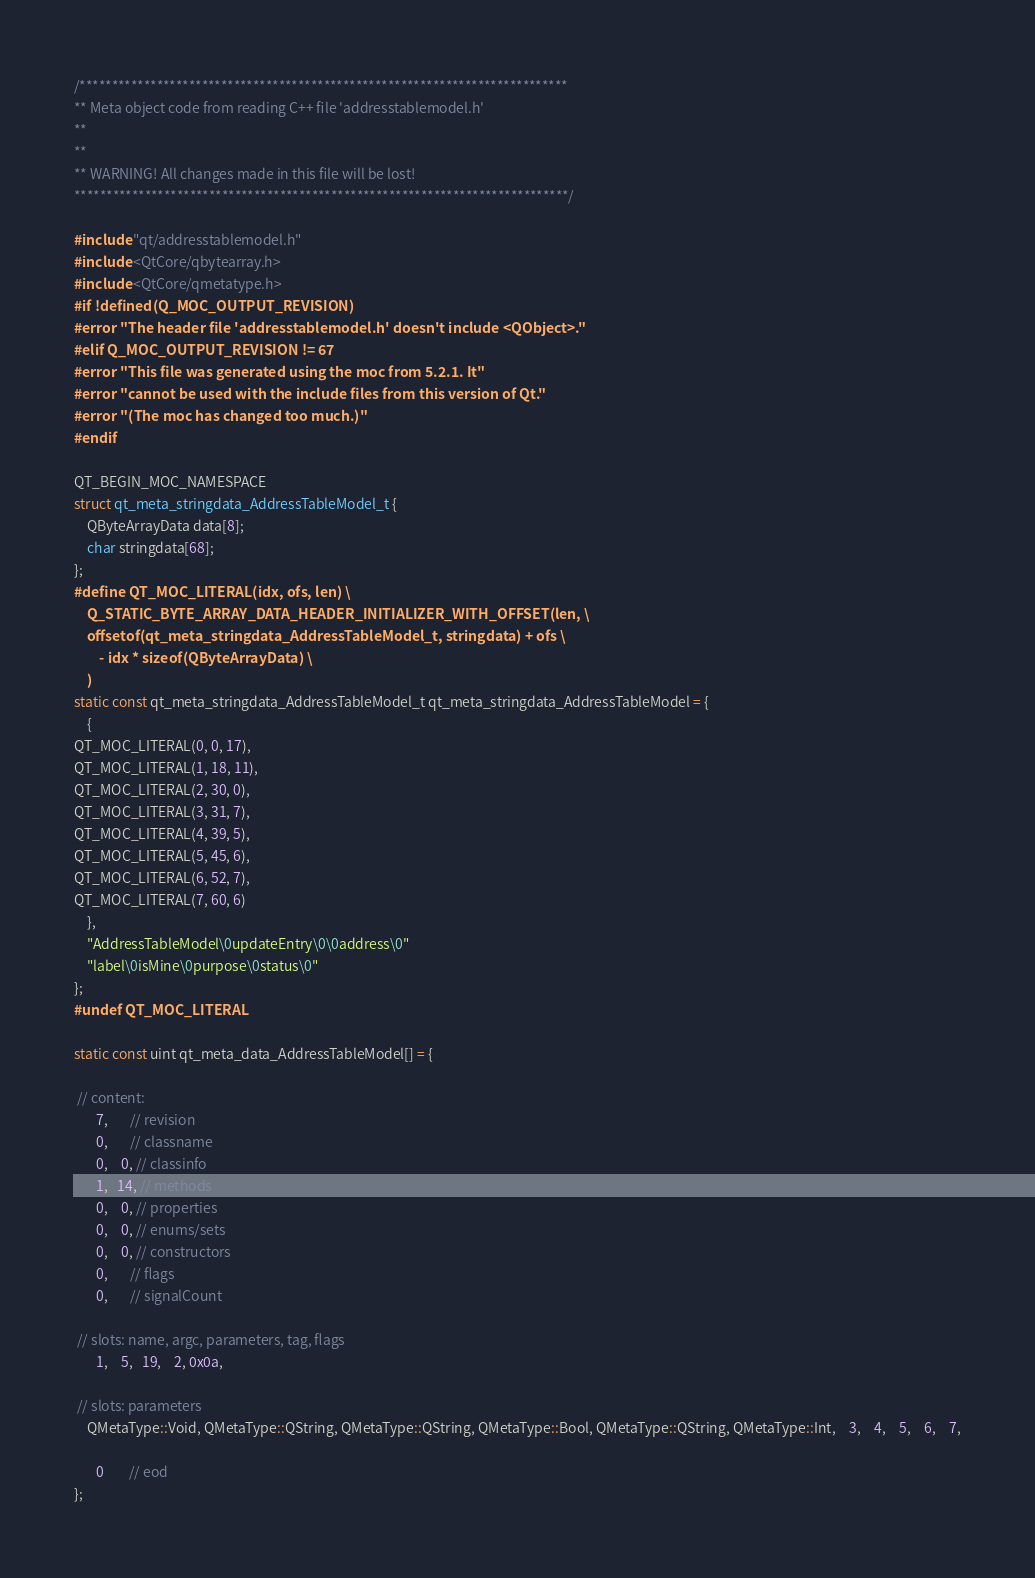Convert code to text. <code><loc_0><loc_0><loc_500><loc_500><_C++_>/****************************************************************************
** Meta object code from reading C++ file 'addresstablemodel.h'
**
**
** WARNING! All changes made in this file will be lost!
*****************************************************************************/

#include "qt/addresstablemodel.h"
#include <QtCore/qbytearray.h>
#include <QtCore/qmetatype.h>
#if !defined(Q_MOC_OUTPUT_REVISION)
#error "The header file 'addresstablemodel.h' doesn't include <QObject>."
#elif Q_MOC_OUTPUT_REVISION != 67
#error "This file was generated using the moc from 5.2.1. It"
#error "cannot be used with the include files from this version of Qt."
#error "(The moc has changed too much.)"
#endif

QT_BEGIN_MOC_NAMESPACE
struct qt_meta_stringdata_AddressTableModel_t {
    QByteArrayData data[8];
    char stringdata[68];
};
#define QT_MOC_LITERAL(idx, ofs, len) \
    Q_STATIC_BYTE_ARRAY_DATA_HEADER_INITIALIZER_WITH_OFFSET(len, \
    offsetof(qt_meta_stringdata_AddressTableModel_t, stringdata) + ofs \
        - idx * sizeof(QByteArrayData) \
    )
static const qt_meta_stringdata_AddressTableModel_t qt_meta_stringdata_AddressTableModel = {
    {
QT_MOC_LITERAL(0, 0, 17),
QT_MOC_LITERAL(1, 18, 11),
QT_MOC_LITERAL(2, 30, 0),
QT_MOC_LITERAL(3, 31, 7),
QT_MOC_LITERAL(4, 39, 5),
QT_MOC_LITERAL(5, 45, 6),
QT_MOC_LITERAL(6, 52, 7),
QT_MOC_LITERAL(7, 60, 6)
    },
    "AddressTableModel\0updateEntry\0\0address\0"
    "label\0isMine\0purpose\0status\0"
};
#undef QT_MOC_LITERAL

static const uint qt_meta_data_AddressTableModel[] = {

 // content:
       7,       // revision
       0,       // classname
       0,    0, // classinfo
       1,   14, // methods
       0,    0, // properties
       0,    0, // enums/sets
       0,    0, // constructors
       0,       // flags
       0,       // signalCount

 // slots: name, argc, parameters, tag, flags
       1,    5,   19,    2, 0x0a,

 // slots: parameters
    QMetaType::Void, QMetaType::QString, QMetaType::QString, QMetaType::Bool, QMetaType::QString, QMetaType::Int,    3,    4,    5,    6,    7,

       0        // eod
};
</code> 